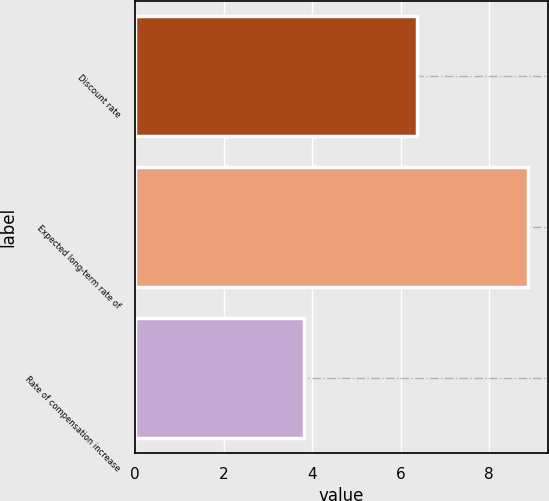Convert chart to OTSL. <chart><loc_0><loc_0><loc_500><loc_500><bar_chart><fcel>Discount rate<fcel>Expected long-term rate of<fcel>Rate of compensation increase<nl><fcel>6.37<fcel>8.88<fcel>3.81<nl></chart> 